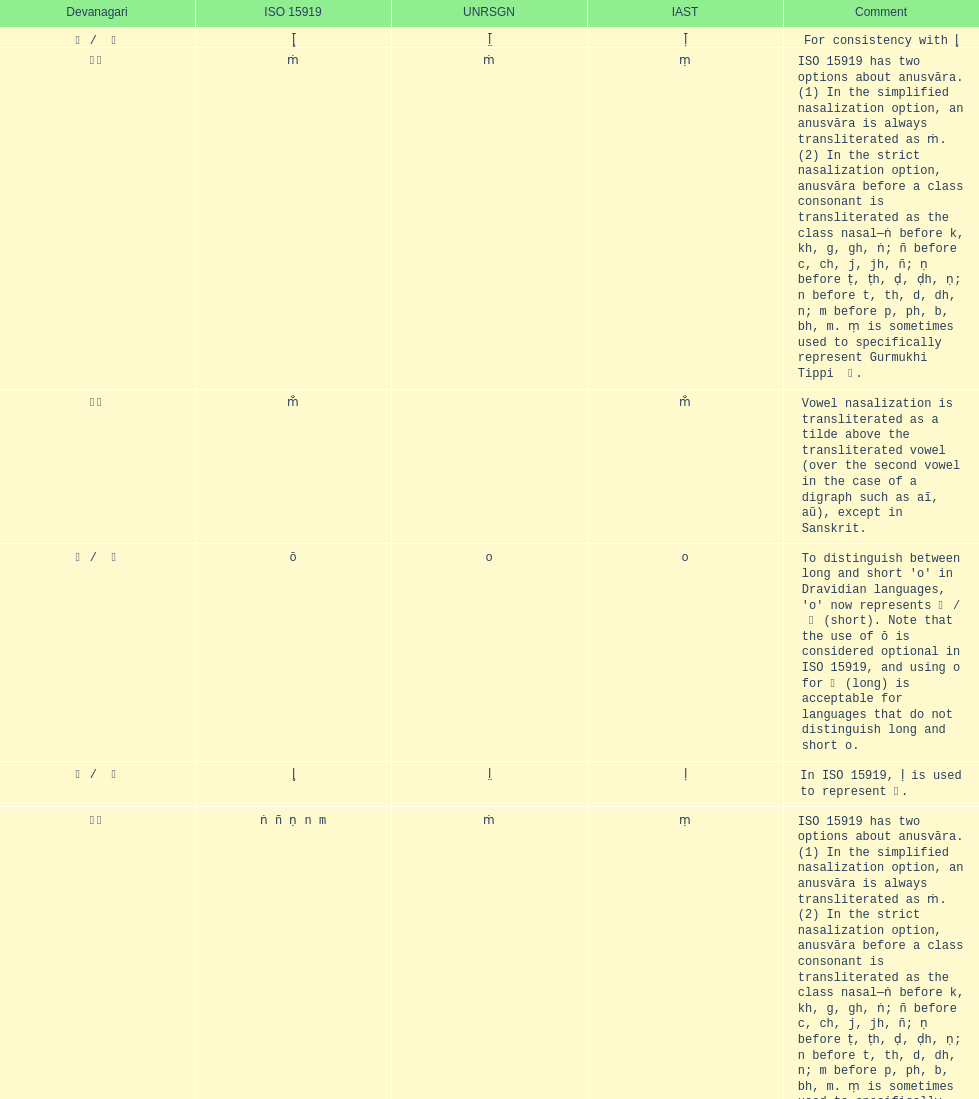How many total options are there about anusvara? 2. 